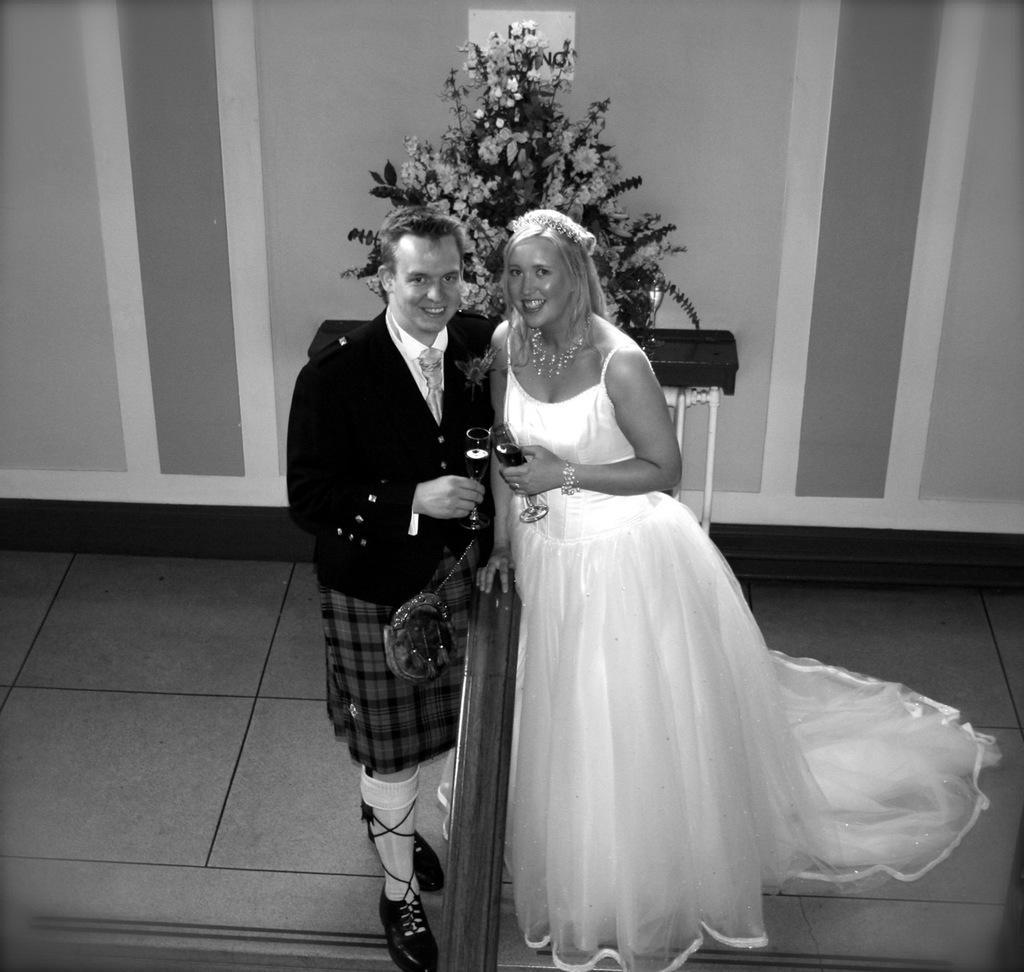How would you summarize this image in a sentence or two? In this black and white picture two people are standing on the floor. They are holding glasses in their hands. Behind them there is a table having a flower vase. Background there is a wall. In between the people there is an object. 